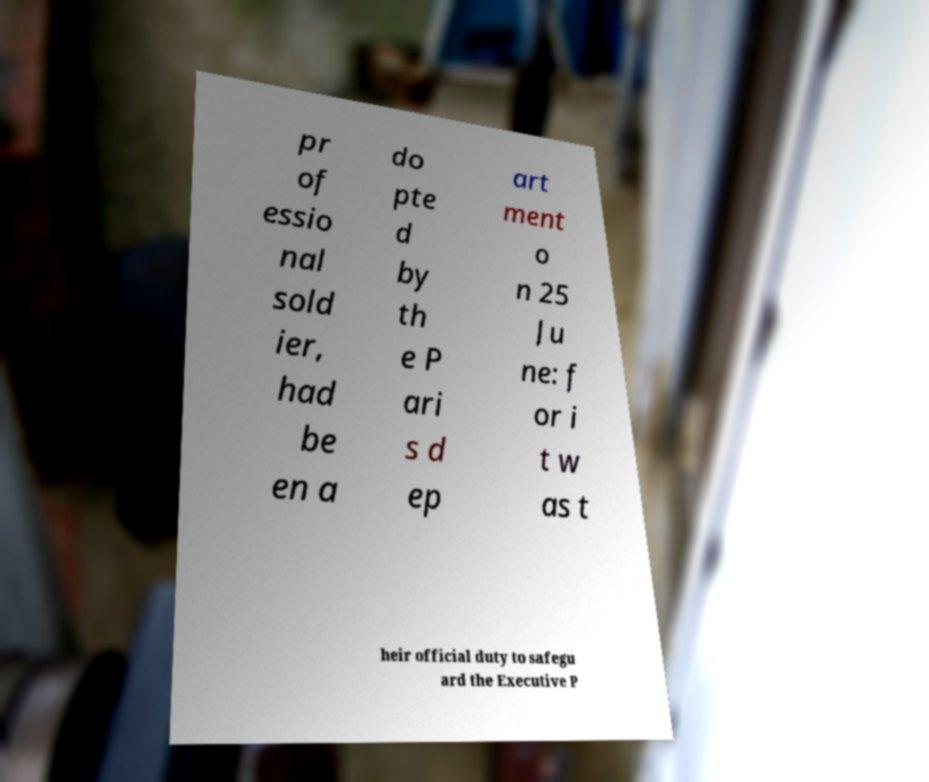Please identify and transcribe the text found in this image. pr of essio nal sold ier, had be en a do pte d by th e P ari s d ep art ment o n 25 Ju ne: f or i t w as t heir official duty to safegu ard the Executive P 